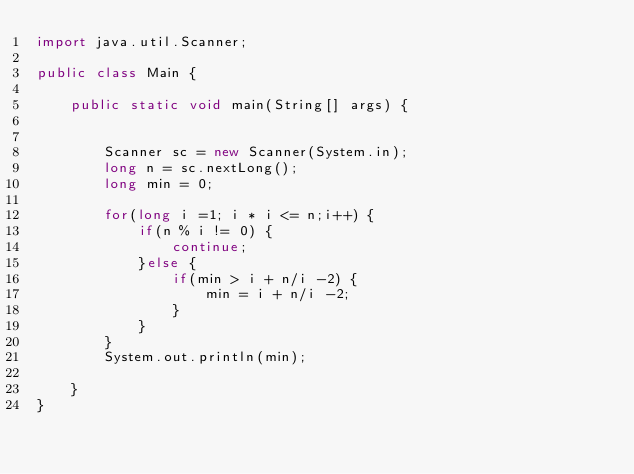<code> <loc_0><loc_0><loc_500><loc_500><_Java_>import java.util.Scanner;

public class Main {

	public static void main(String[] args) {


		Scanner sc = new Scanner(System.in);
		long n = sc.nextLong();
		long min = 0;

		for(long i =1; i * i <= n;i++) {
			if(n % i != 0) {
				continue;
			}else {
				if(min > i + n/i -2) {
					min = i + n/i -2;
				}
			}
		}
		System.out.println(min);

	}
}</code> 